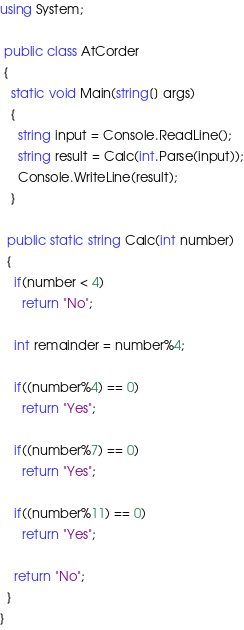<code> <loc_0><loc_0><loc_500><loc_500><_C#_>using System;

 public class AtCorder
 {
   static void Main(string[] args)
   {
     string input = Console.ReadLine();
     string result = Calc(int.Parse(input));
     Console.WriteLine(result);
   }
   
  public static string Calc(int number)
  {
    if(number < 4)
      return "No";
    
    int remainder = number%4;
    
    if((number%4) == 0)
      return "Yes";
    
    if((number%7) == 0)
      return "Yes";
    
    if((number%11) == 0)
      return "Yes";
    
    return "No";
  }
}</code> 